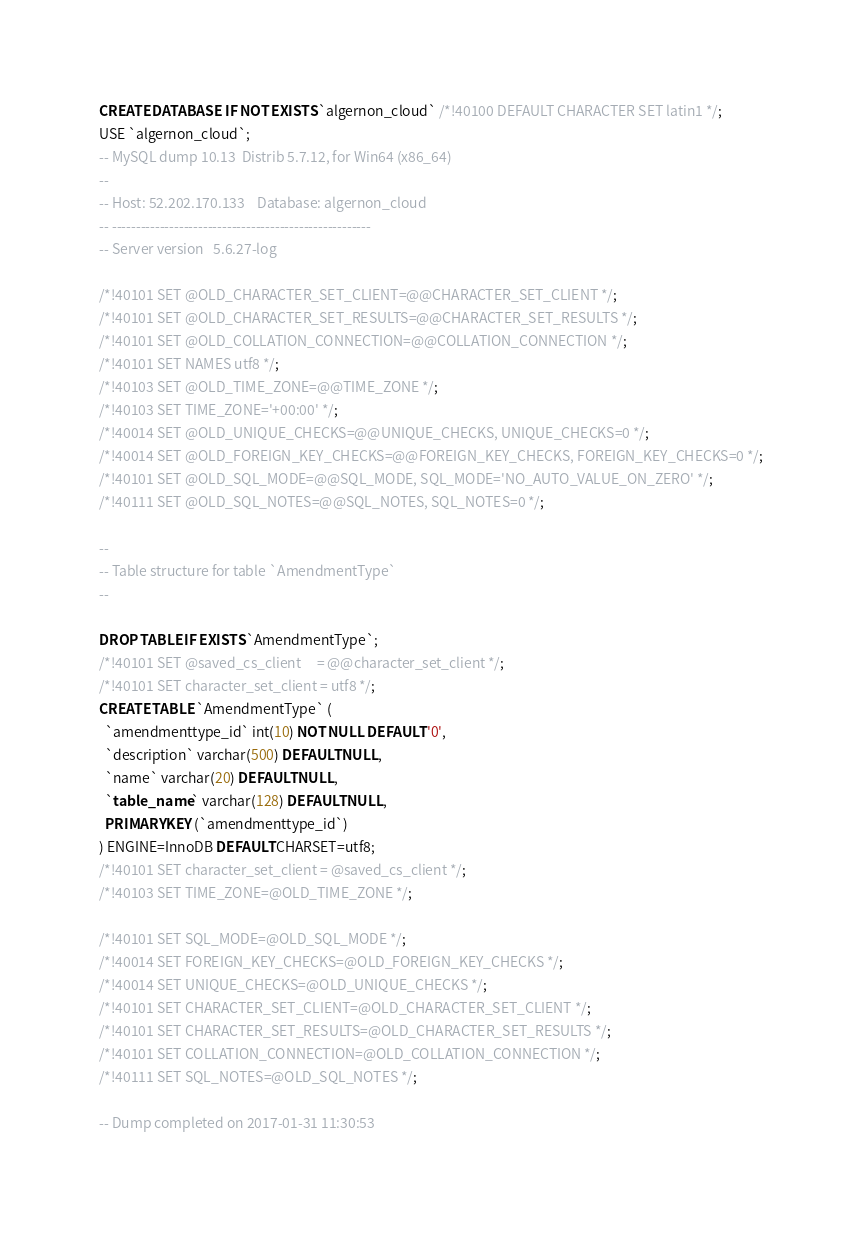<code> <loc_0><loc_0><loc_500><loc_500><_SQL_>CREATE DATABASE  IF NOT EXISTS `algernon_cloud` /*!40100 DEFAULT CHARACTER SET latin1 */;
USE `algernon_cloud`;
-- MySQL dump 10.13  Distrib 5.7.12, for Win64 (x86_64)
--
-- Host: 52.202.170.133    Database: algernon_cloud
-- ------------------------------------------------------
-- Server version	5.6.27-log

/*!40101 SET @OLD_CHARACTER_SET_CLIENT=@@CHARACTER_SET_CLIENT */;
/*!40101 SET @OLD_CHARACTER_SET_RESULTS=@@CHARACTER_SET_RESULTS */;
/*!40101 SET @OLD_COLLATION_CONNECTION=@@COLLATION_CONNECTION */;
/*!40101 SET NAMES utf8 */;
/*!40103 SET @OLD_TIME_ZONE=@@TIME_ZONE */;
/*!40103 SET TIME_ZONE='+00:00' */;
/*!40014 SET @OLD_UNIQUE_CHECKS=@@UNIQUE_CHECKS, UNIQUE_CHECKS=0 */;
/*!40014 SET @OLD_FOREIGN_KEY_CHECKS=@@FOREIGN_KEY_CHECKS, FOREIGN_KEY_CHECKS=0 */;
/*!40101 SET @OLD_SQL_MODE=@@SQL_MODE, SQL_MODE='NO_AUTO_VALUE_ON_ZERO' */;
/*!40111 SET @OLD_SQL_NOTES=@@SQL_NOTES, SQL_NOTES=0 */;

--
-- Table structure for table `AmendmentType`
--

DROP TABLE IF EXISTS `AmendmentType`;
/*!40101 SET @saved_cs_client     = @@character_set_client */;
/*!40101 SET character_set_client = utf8 */;
CREATE TABLE `AmendmentType` (
  `amendmenttype_id` int(10) NOT NULL DEFAULT '0',
  `description` varchar(500) DEFAULT NULL,
  `name` varchar(20) DEFAULT NULL,
  `table_name` varchar(128) DEFAULT NULL,
  PRIMARY KEY (`amendmenttype_id`)
) ENGINE=InnoDB DEFAULT CHARSET=utf8;
/*!40101 SET character_set_client = @saved_cs_client */;
/*!40103 SET TIME_ZONE=@OLD_TIME_ZONE */;

/*!40101 SET SQL_MODE=@OLD_SQL_MODE */;
/*!40014 SET FOREIGN_KEY_CHECKS=@OLD_FOREIGN_KEY_CHECKS */;
/*!40014 SET UNIQUE_CHECKS=@OLD_UNIQUE_CHECKS */;
/*!40101 SET CHARACTER_SET_CLIENT=@OLD_CHARACTER_SET_CLIENT */;
/*!40101 SET CHARACTER_SET_RESULTS=@OLD_CHARACTER_SET_RESULTS */;
/*!40101 SET COLLATION_CONNECTION=@OLD_COLLATION_CONNECTION */;
/*!40111 SET SQL_NOTES=@OLD_SQL_NOTES */;

-- Dump completed on 2017-01-31 11:30:53
</code> 